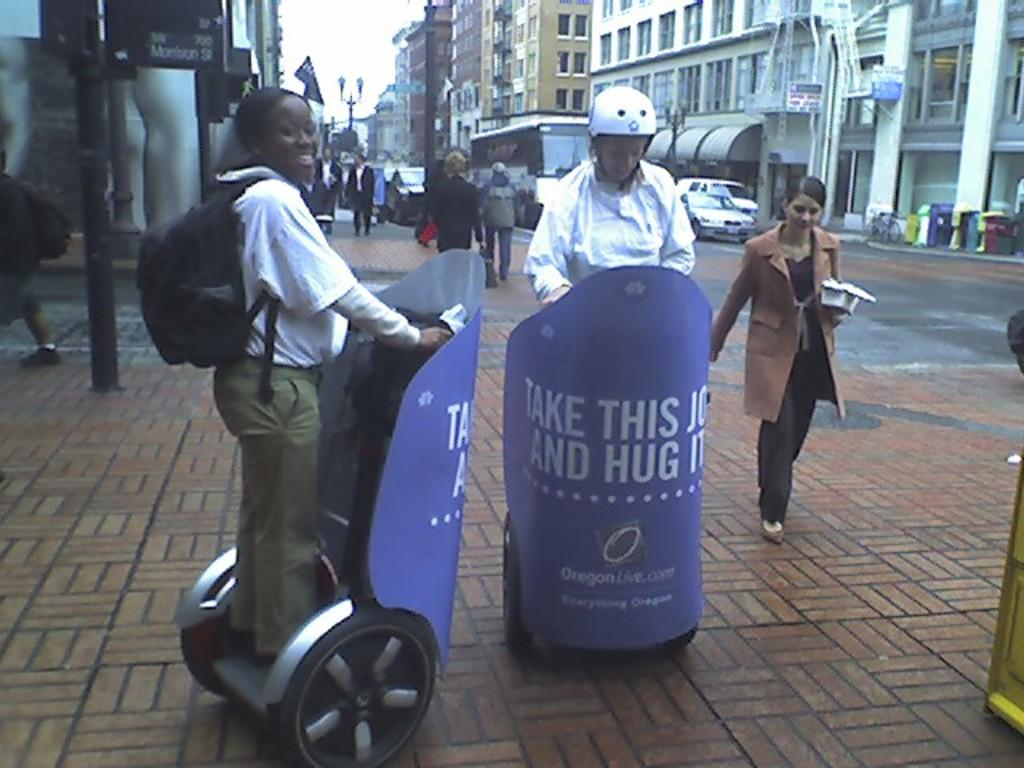How many people can be seen in the image? There are people in the image. What else is present in the image besides people? There are vehicles, buildings, poles, boards, and objects in the image. Can you describe the activity of two people in the image? Two people are riding segways on a path in the image. What type of knee injury is visible on the person riding the segway? There is no knee injury visible on the person riding the segway, as the image does not show any injuries. 